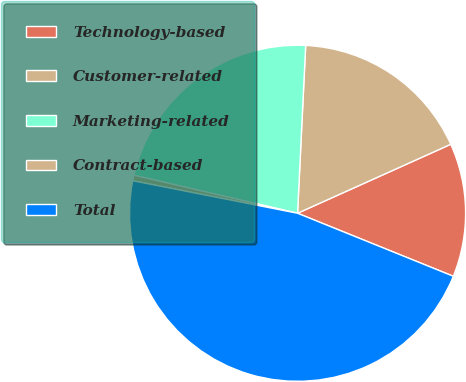<chart> <loc_0><loc_0><loc_500><loc_500><pie_chart><fcel>Technology-based<fcel>Customer-related<fcel>Marketing-related<fcel>Contract-based<fcel>Total<nl><fcel>12.85%<fcel>17.5%<fcel>22.14%<fcel>0.53%<fcel>46.99%<nl></chart> 